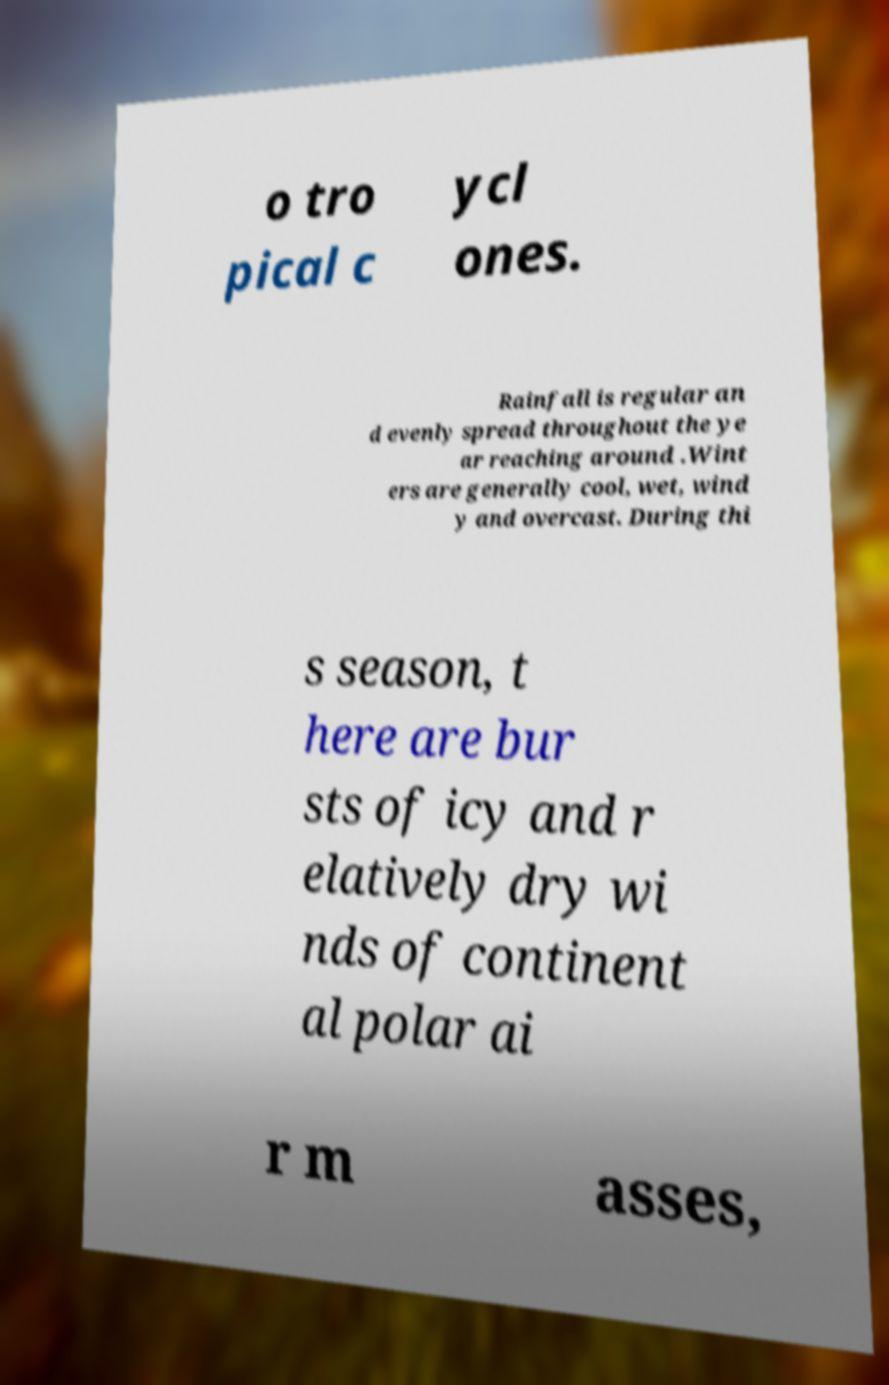I need the written content from this picture converted into text. Can you do that? o tro pical c ycl ones. Rainfall is regular an d evenly spread throughout the ye ar reaching around .Wint ers are generally cool, wet, wind y and overcast. During thi s season, t here are bur sts of icy and r elatively dry wi nds of continent al polar ai r m asses, 